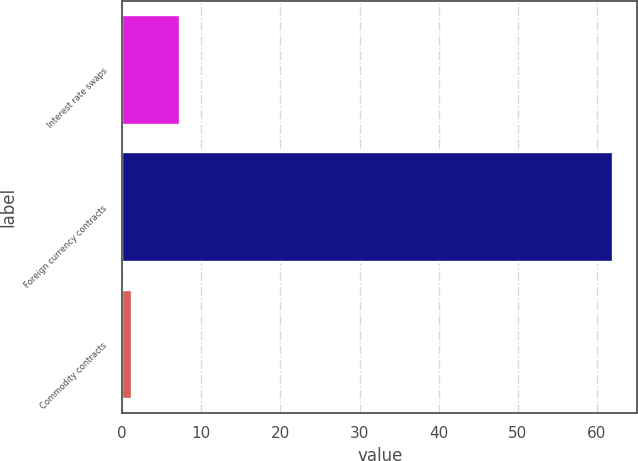<chart> <loc_0><loc_0><loc_500><loc_500><bar_chart><fcel>Interest rate swaps<fcel>Foreign currency contracts<fcel>Commodity contracts<nl><fcel>7.28<fcel>62<fcel>1.2<nl></chart> 